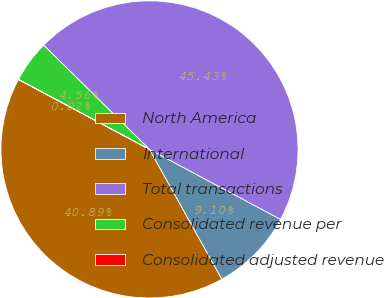<chart> <loc_0><loc_0><loc_500><loc_500><pie_chart><fcel>North America<fcel>International<fcel>Total transactions<fcel>Consolidated revenue per<fcel>Consolidated adjusted revenue<nl><fcel>40.89%<fcel>9.1%<fcel>45.43%<fcel>4.56%<fcel>0.02%<nl></chart> 